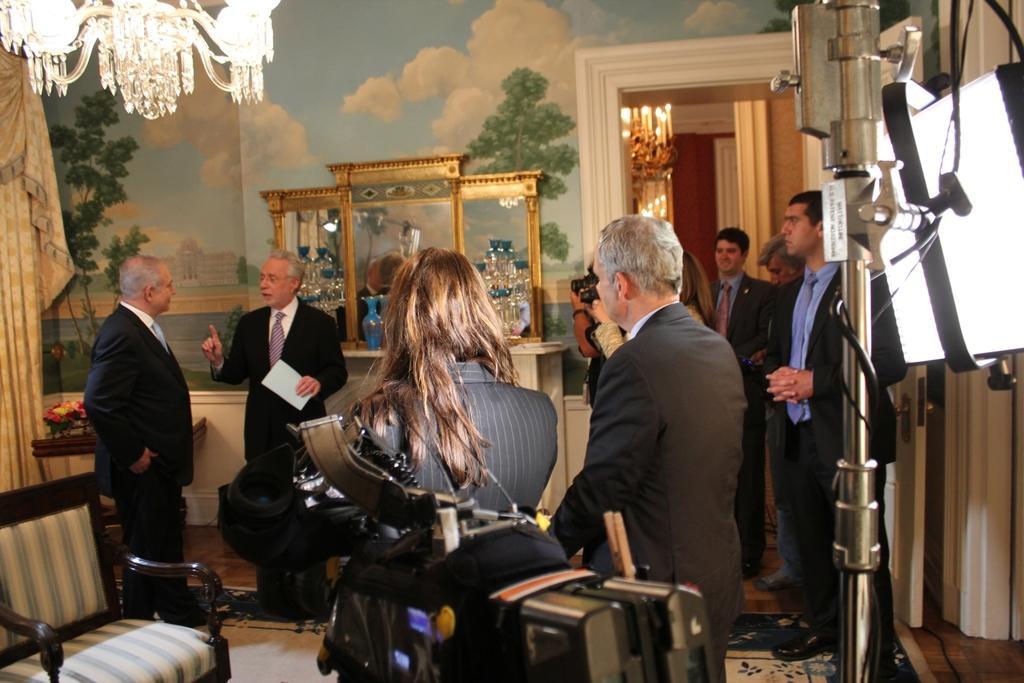Please provide a concise description of this image. In this image we can see people standing in a room. They are wearing suit. There is a chair, curtains on the left. There is a stand and a light on the right. There is a chandelier at the top and there is a mirror and painting on the wall at the back. 